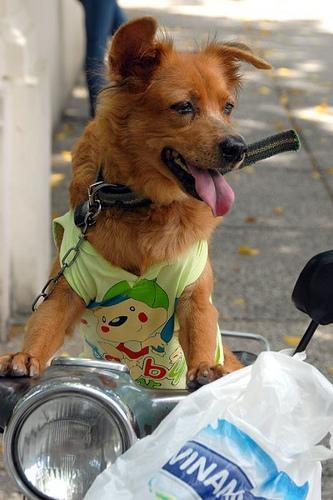How many people are there?
Give a very brief answer. 1. 